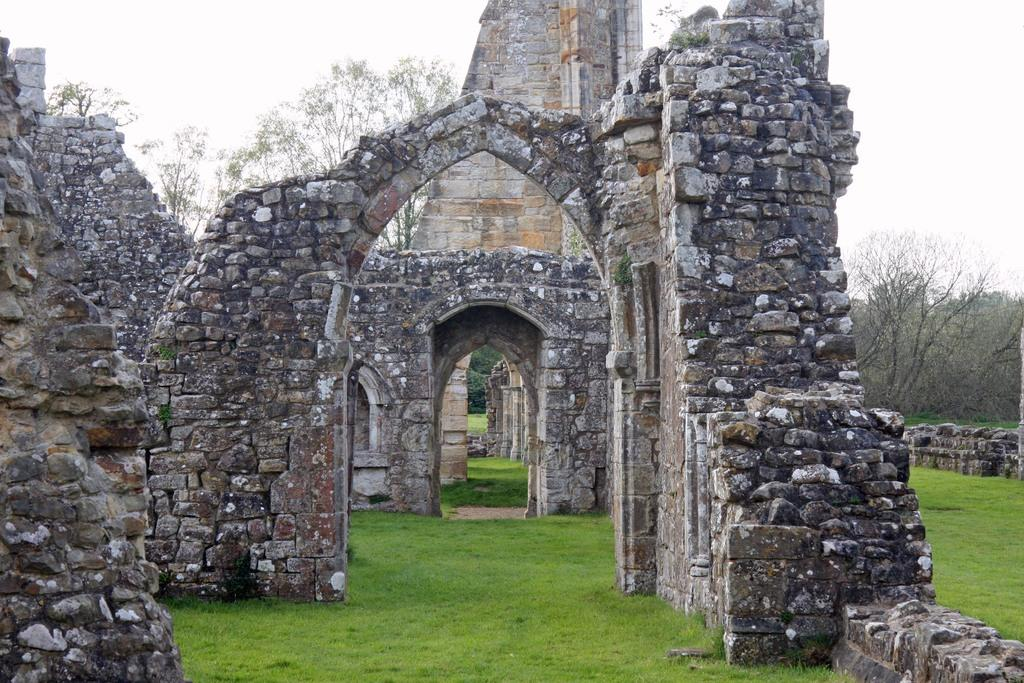What type of structure is in the image? There is a fort in the image. What can be seen in the background of the image? There are dried trees in the background of the image. What is the color of the grass in the image? The grass in the image is green. What is the color of the sky in the image? The sky is white in color. What type of engine can be seen powering the fort in the image? There is no engine present in the image, as the fort is likely a historical or architectural structure and not a functioning vehicle or machine. 